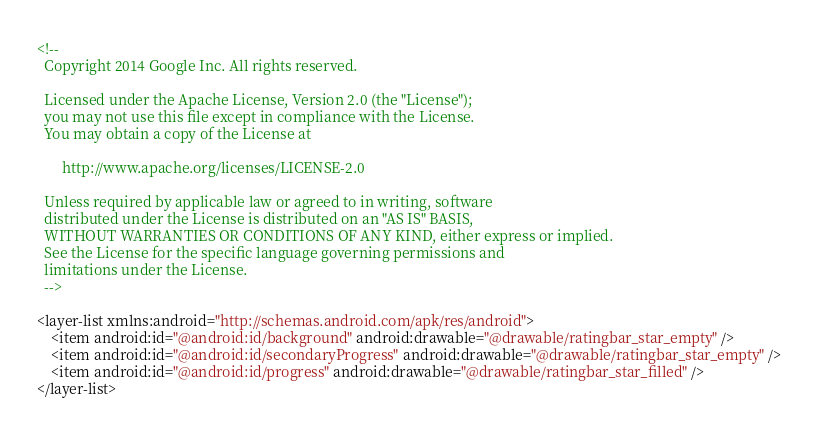<code> <loc_0><loc_0><loc_500><loc_500><_XML_><!--
  Copyright 2014 Google Inc. All rights reserved.

  Licensed under the Apache License, Version 2.0 (the "License");
  you may not use this file except in compliance with the License.
  You may obtain a copy of the License at

       http://www.apache.org/licenses/LICENSE-2.0

  Unless required by applicable law or agreed to in writing, software
  distributed under the License is distributed on an "AS IS" BASIS,
  WITHOUT WARRANTIES OR CONDITIONS OF ANY KIND, either express or implied.
  See the License for the specific language governing permissions and
  limitations under the License.
  -->

<layer-list xmlns:android="http://schemas.android.com/apk/res/android">
    <item android:id="@android:id/background" android:drawable="@drawable/ratingbar_star_empty" />
    <item android:id="@android:id/secondaryProgress" android:drawable="@drawable/ratingbar_star_empty" />
    <item android:id="@android:id/progress" android:drawable="@drawable/ratingbar_star_filled" />
</layer-list>
</code> 